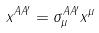<formula> <loc_0><loc_0><loc_500><loc_500>x ^ { A A ^ { \prime } } = \sigma _ { \mu } ^ { A A ^ { \prime } } x ^ { \mu }</formula> 